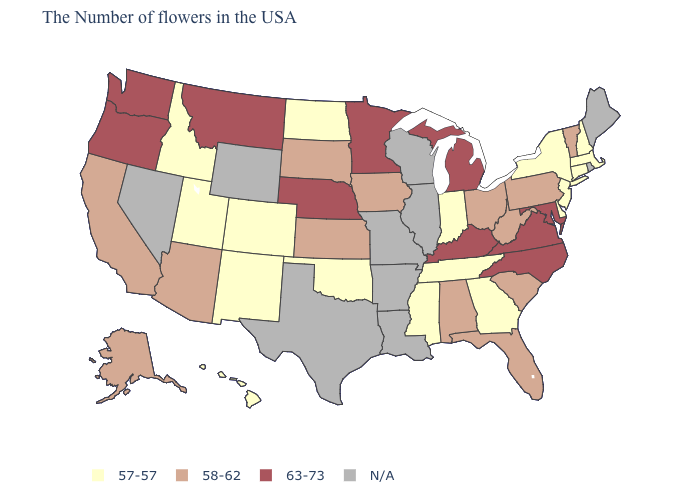Does Kansas have the highest value in the USA?
Write a very short answer. No. What is the value of Illinois?
Quick response, please. N/A. How many symbols are there in the legend?
Answer briefly. 4. What is the highest value in the MidWest ?
Concise answer only. 63-73. What is the value of Virginia?
Answer briefly. 63-73. What is the lowest value in the MidWest?
Be succinct. 57-57. Name the states that have a value in the range 57-57?
Write a very short answer. Massachusetts, New Hampshire, Connecticut, New York, New Jersey, Delaware, Georgia, Indiana, Tennessee, Mississippi, Oklahoma, North Dakota, Colorado, New Mexico, Utah, Idaho, Hawaii. Name the states that have a value in the range N/A?
Be succinct. Maine, Rhode Island, Wisconsin, Illinois, Louisiana, Missouri, Arkansas, Texas, Wyoming, Nevada. Name the states that have a value in the range 58-62?
Quick response, please. Vermont, Pennsylvania, South Carolina, West Virginia, Ohio, Florida, Alabama, Iowa, Kansas, South Dakota, Arizona, California, Alaska. What is the value of Louisiana?
Give a very brief answer. N/A. Name the states that have a value in the range N/A?
Give a very brief answer. Maine, Rhode Island, Wisconsin, Illinois, Louisiana, Missouri, Arkansas, Texas, Wyoming, Nevada. What is the lowest value in states that border Nebraska?
Answer briefly. 57-57. What is the highest value in the South ?
Quick response, please. 63-73. 